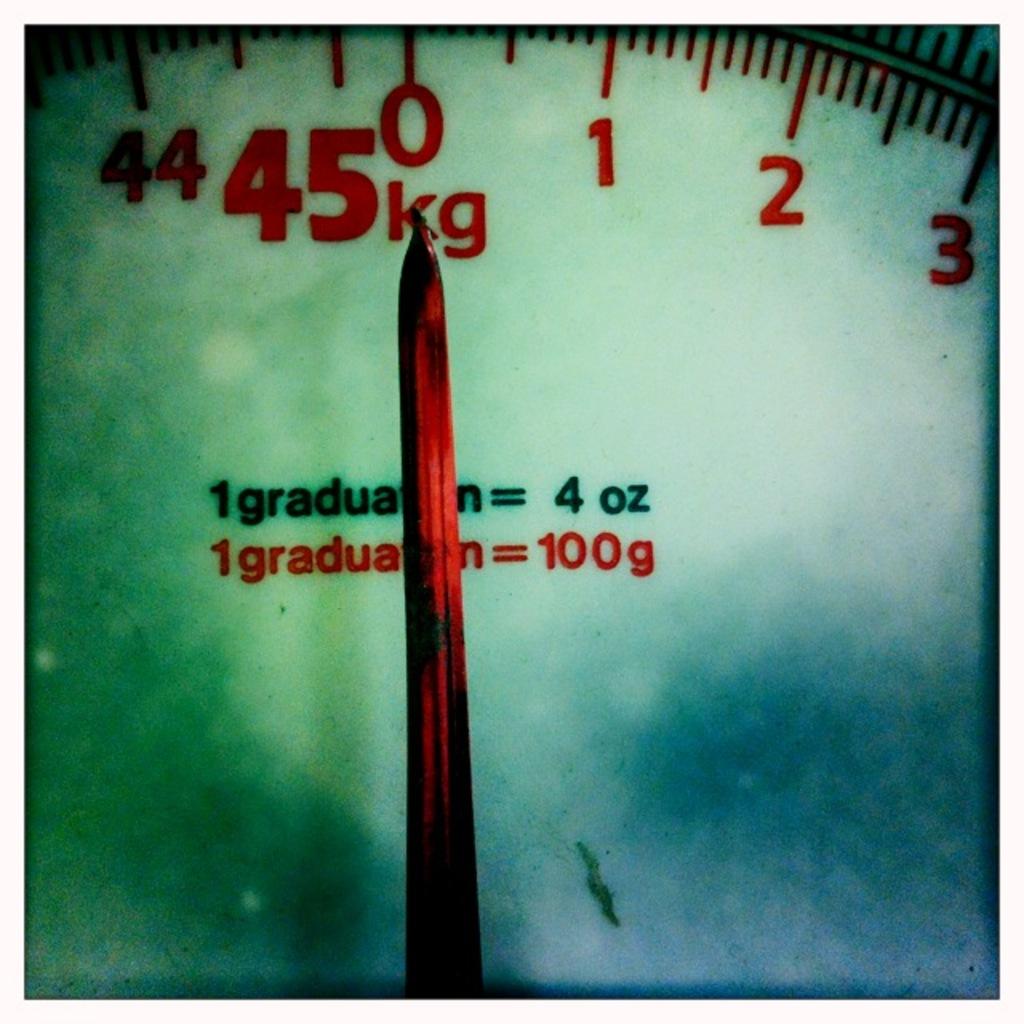How many kilograms can this scale go up to?
Provide a succinct answer. 45. What is 1 graduation equal to with the red text?
Provide a succinct answer. 100g. 